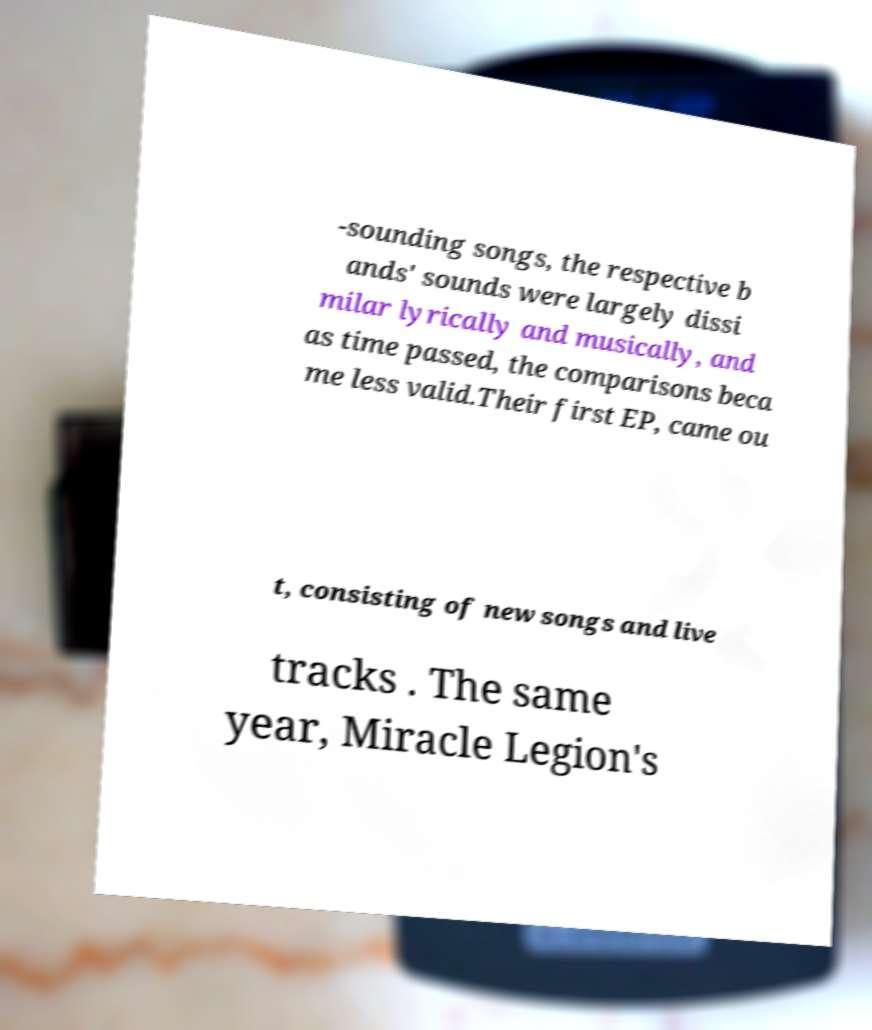There's text embedded in this image that I need extracted. Can you transcribe it verbatim? -sounding songs, the respective b ands' sounds were largely dissi milar lyrically and musically, and as time passed, the comparisons beca me less valid.Their first EP, came ou t, consisting of new songs and live tracks . The same year, Miracle Legion's 